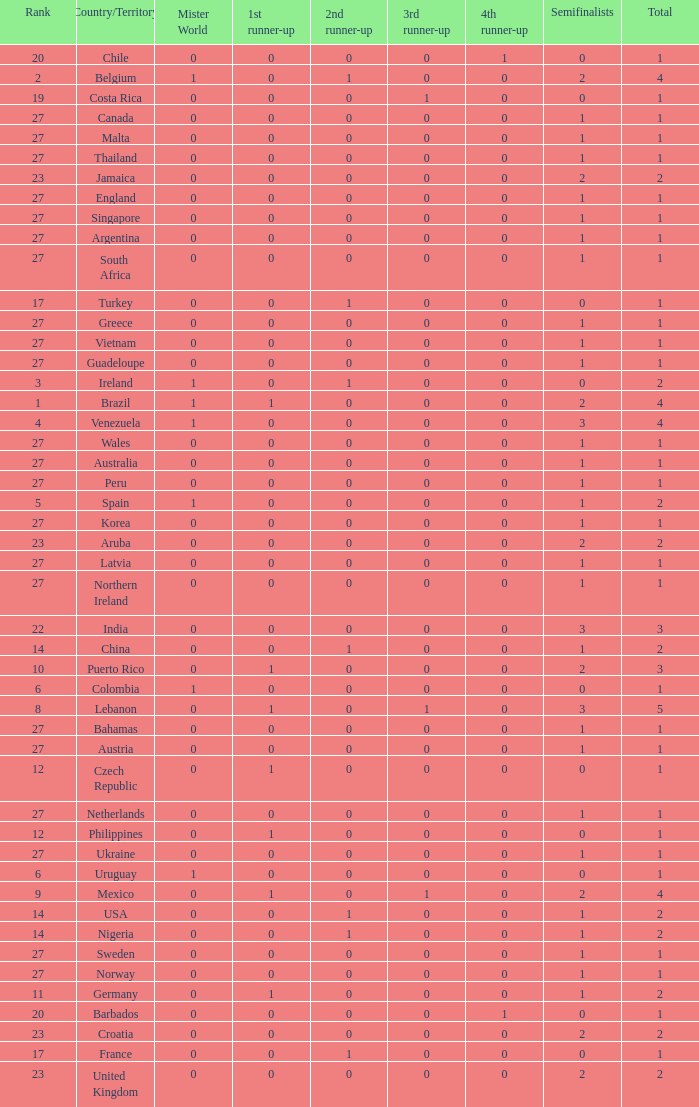What is the number of 1st runner up values for Jamaica? 1.0. 